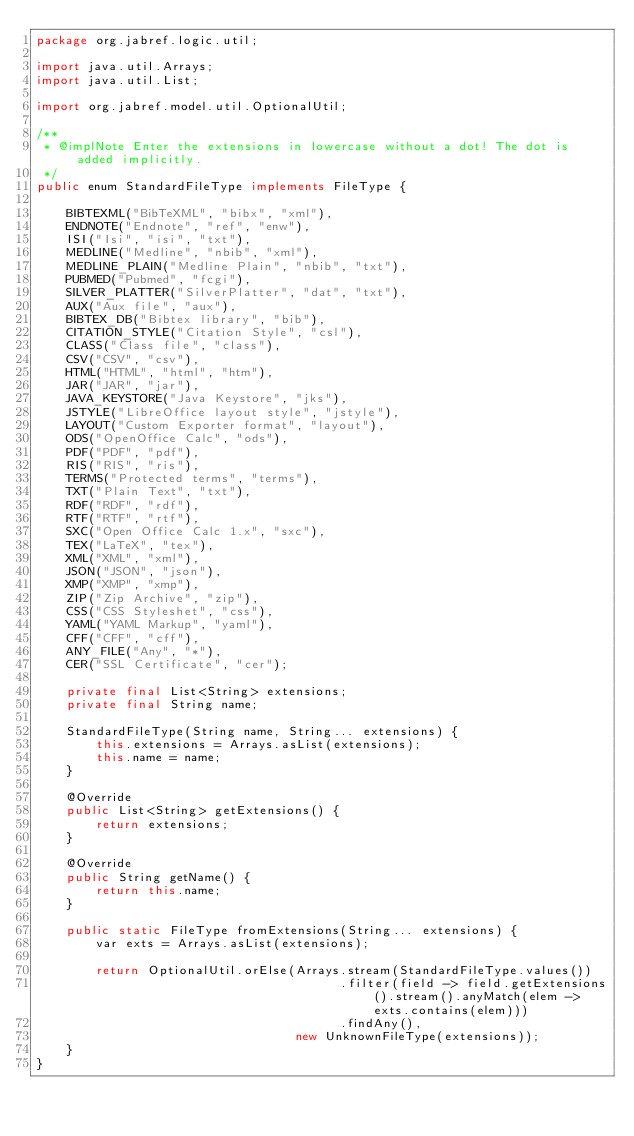<code> <loc_0><loc_0><loc_500><loc_500><_Java_>package org.jabref.logic.util;

import java.util.Arrays;
import java.util.List;

import org.jabref.model.util.OptionalUtil;

/**
 * @implNote Enter the extensions in lowercase without a dot! The dot is added implicitly.
 */
public enum StandardFileType implements FileType {

    BIBTEXML("BibTeXML", "bibx", "xml"),
    ENDNOTE("Endnote", "ref", "enw"),
    ISI("Isi", "isi", "txt"),
    MEDLINE("Medline", "nbib", "xml"),
    MEDLINE_PLAIN("Medline Plain", "nbib", "txt"),
    PUBMED("Pubmed", "fcgi"),
    SILVER_PLATTER("SilverPlatter", "dat", "txt"),
    AUX("Aux file", "aux"),
    BIBTEX_DB("Bibtex library", "bib"),
    CITATION_STYLE("Citation Style", "csl"),
    CLASS("Class file", "class"),
    CSV("CSV", "csv"),
    HTML("HTML", "html", "htm"),
    JAR("JAR", "jar"),
    JAVA_KEYSTORE("Java Keystore", "jks"),
    JSTYLE("LibreOffice layout style", "jstyle"),
    LAYOUT("Custom Exporter format", "layout"),
    ODS("OpenOffice Calc", "ods"),
    PDF("PDF", "pdf"),
    RIS("RIS", "ris"),
    TERMS("Protected terms", "terms"),
    TXT("Plain Text", "txt"),
    RDF("RDF", "rdf"),
    RTF("RTF", "rtf"),
    SXC("Open Office Calc 1.x", "sxc"),
    TEX("LaTeX", "tex"),
    XML("XML", "xml"),
    JSON("JSON", "json"),
    XMP("XMP", "xmp"),
    ZIP("Zip Archive", "zip"),
    CSS("CSS Styleshet", "css"),
    YAML("YAML Markup", "yaml"),
    CFF("CFF", "cff"),
    ANY_FILE("Any", "*"),
    CER("SSL Certificate", "cer");

    private final List<String> extensions;
    private final String name;

    StandardFileType(String name, String... extensions) {
        this.extensions = Arrays.asList(extensions);
        this.name = name;
    }

    @Override
    public List<String> getExtensions() {
        return extensions;
    }

    @Override
    public String getName() {
        return this.name;
    }

    public static FileType fromExtensions(String... extensions) {
        var exts = Arrays.asList(extensions);

        return OptionalUtil.orElse(Arrays.stream(StandardFileType.values())
                                         .filter(field -> field.getExtensions().stream().anyMatch(elem -> exts.contains(elem)))
                                         .findAny(),
                                   new UnknownFileType(extensions));
    }
}
</code> 